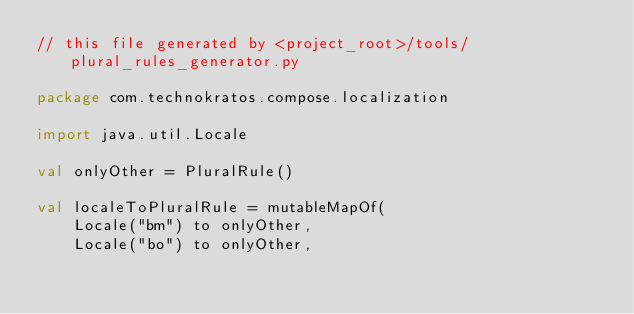<code> <loc_0><loc_0><loc_500><loc_500><_Kotlin_>// this file generated by <project_root>/tools/plural_rules_generator.py

package com.technokratos.compose.localization

import java.util.Locale

val onlyOther = PluralRule()

val localeToPluralRule = mutableMapOf(
    Locale("bm") to onlyOther,
    Locale("bo") to onlyOther,</code> 